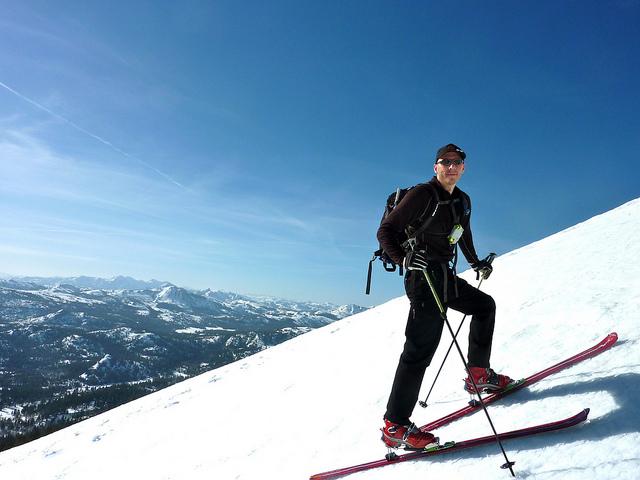What color are his shoes?
Short answer required. Red. Is it a sunny day?
Give a very brief answer. Yes. What is he holding in his hands?
Short answer required. Ski poles. What does the skier see ahead?
Give a very brief answer. Mountains. 